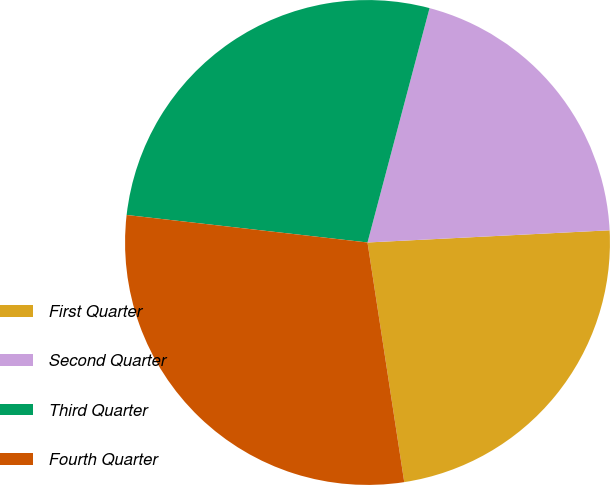Convert chart. <chart><loc_0><loc_0><loc_500><loc_500><pie_chart><fcel>First Quarter<fcel>Second Quarter<fcel>Third Quarter<fcel>Fourth Quarter<nl><fcel>23.38%<fcel>20.08%<fcel>27.31%<fcel>29.23%<nl></chart> 